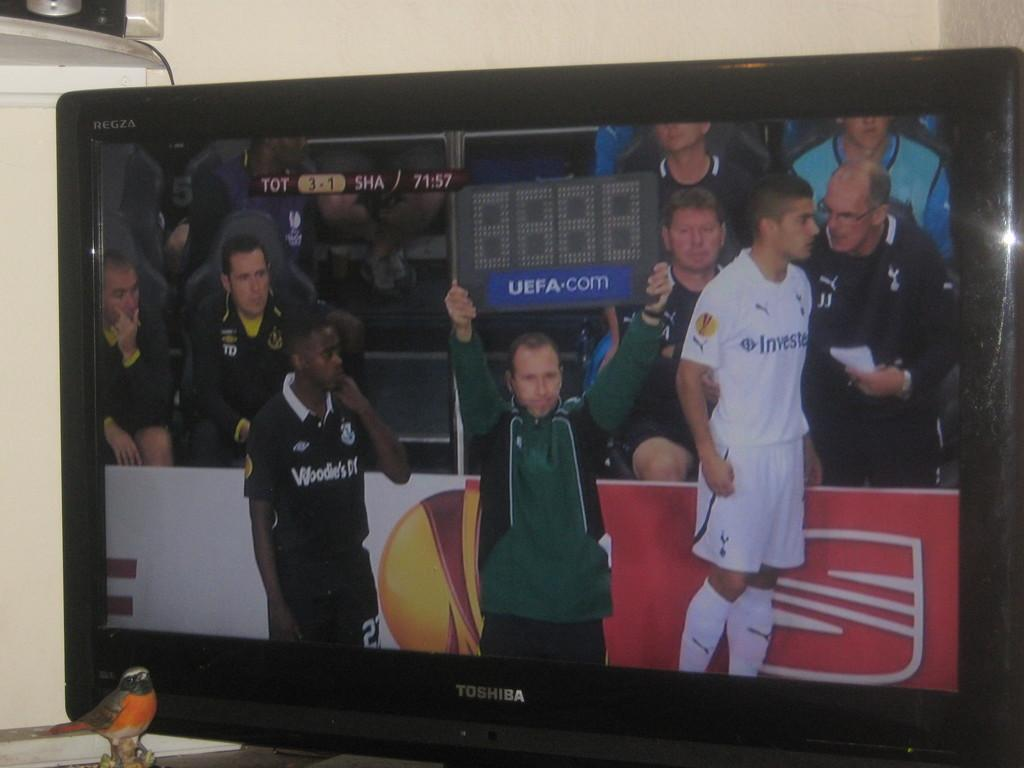What is the main subject of the image? There is a person standing in the middle of the image. What is the person wearing? The person is wearing a green dress. Are there any other people in the image? Yes, there is another man standing on the right side of the image. What is the man wearing? The man is wearing a white dress. How does the boy express his pain in the image? There is no boy present in the image, and no one is expressing pain. 